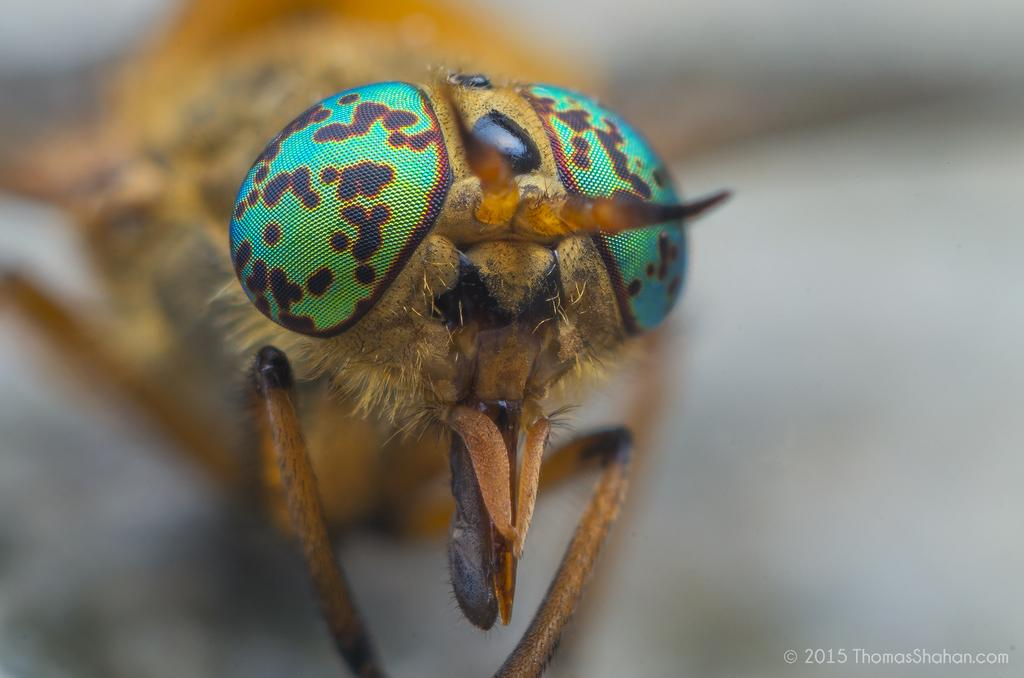What type of insect can be seen in the image? There is a fly present in the image. What time of day is it at the seashore in the image? There is no seashore present in the image; it only features a fly. 